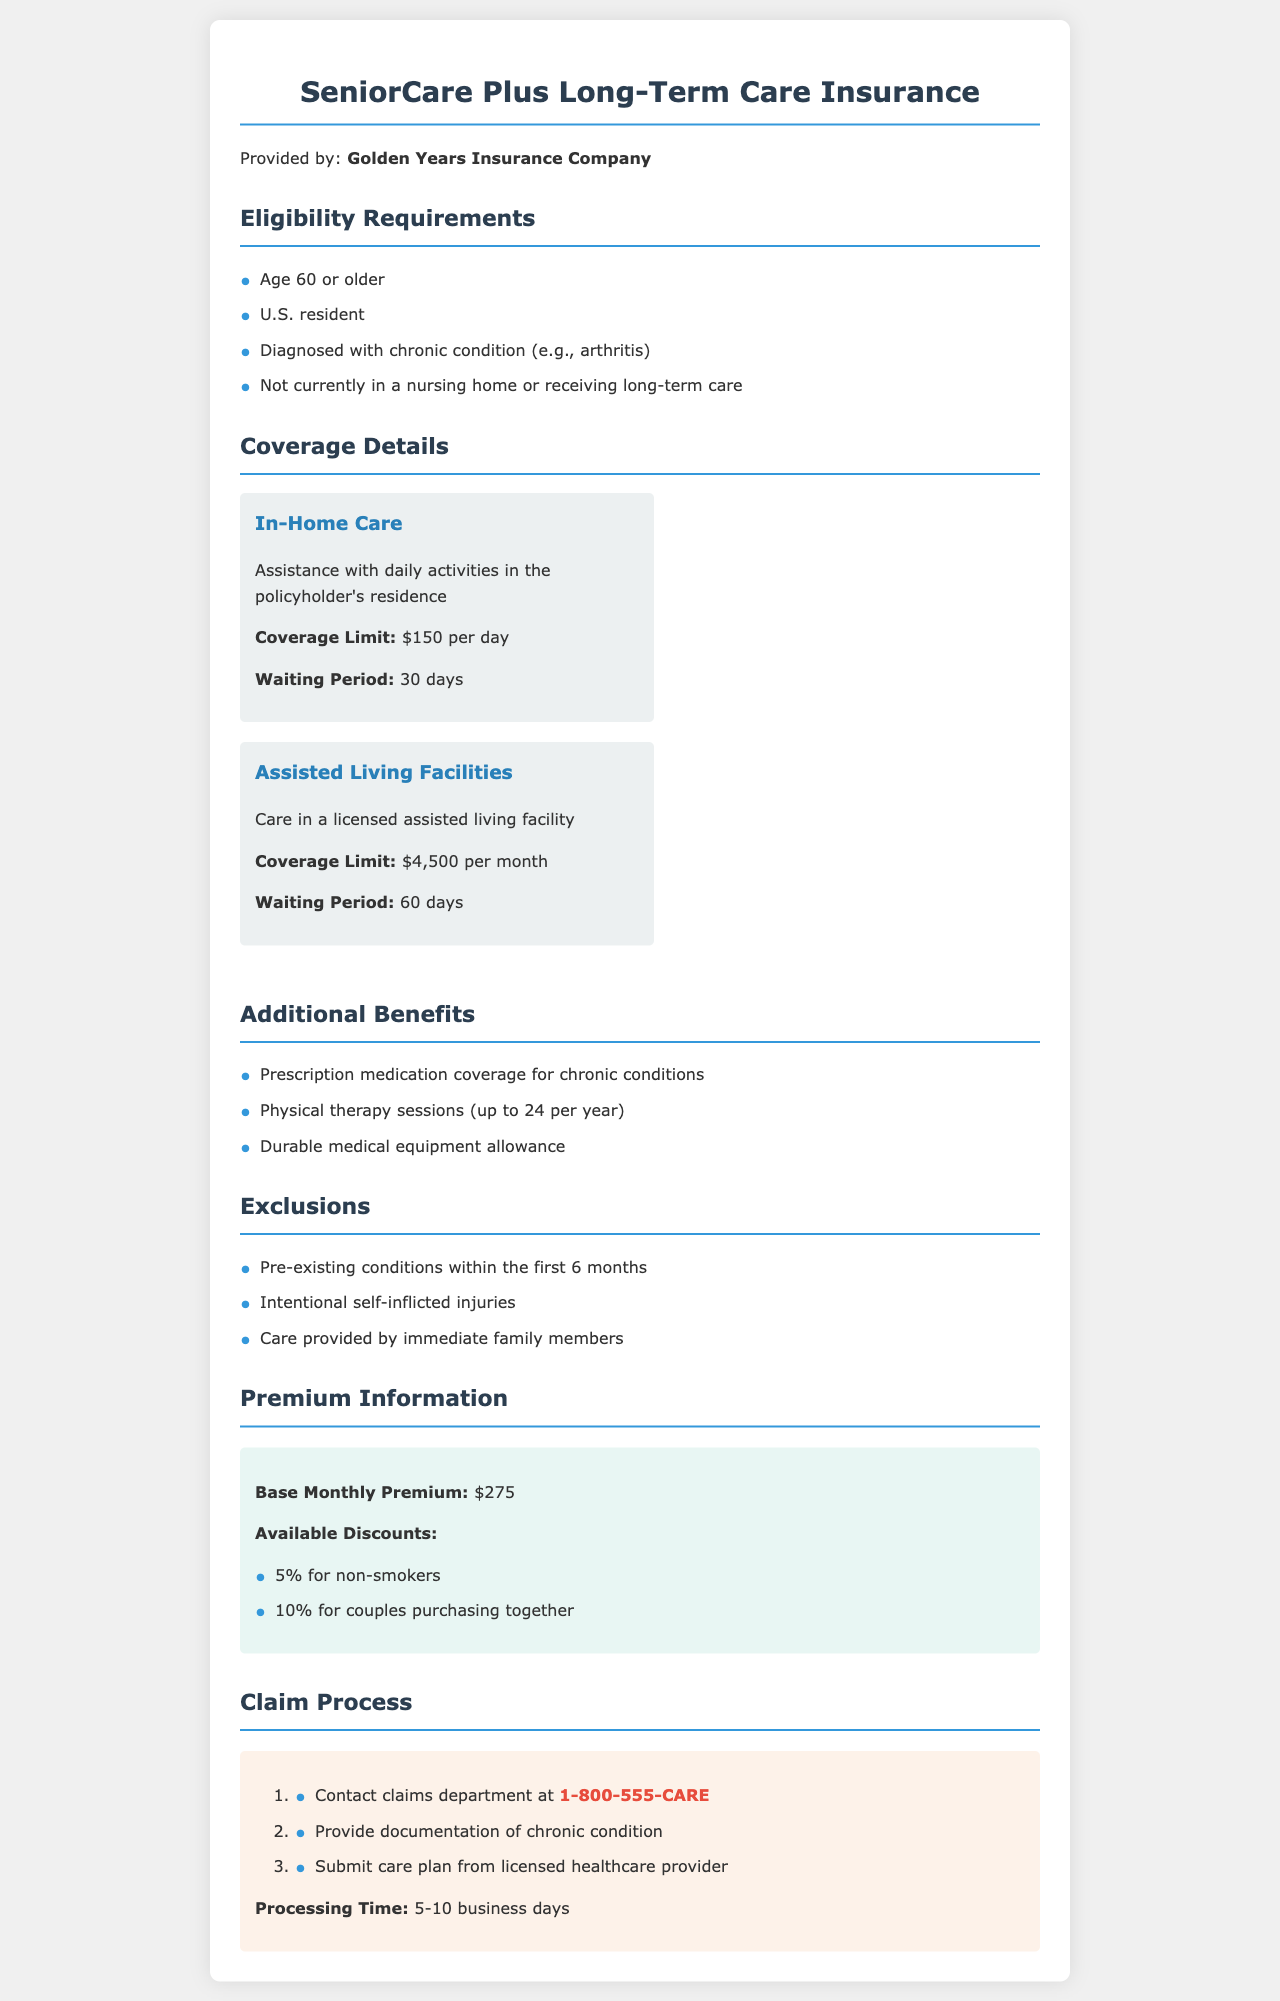What is the maximum daily coverage for in-home care? The maximum daily coverage for in-home care is specified in the document under coverage details.
Answer: $150 per day What is the waiting period for assisted living facility coverage? The waiting period for assisted living facility coverage is mentioned in the document.
Answer: 60 days What additional benefit includes up to 24 sessions per year? The document mentions additional benefits, one of which refers to sessions per year.
Answer: Physical therapy sessions Who provides the SeniorCare Plus Long-Term Care Insurance? The provider of the SeniorCare Plus Long-Term Care Insurance is given at the beginning of the document.
Answer: Golden Years Insurance Company What is the base monthly premium for this long-term care insurance? The base monthly premium can be found in the premium information section of the document.
Answer: $275 What is excluded regarding pre-existing conditions? Exclusions are detailed in the document, indicating something about pre-existing conditions.
Answer: Within the first 6 months How long does the claim process typically take? The processing time for claims is specified in the claim process section of the document.
Answer: 5-10 business days What chronic condition is specifically mentioned in eligibility requirements? The eligibility requirements list a certain chronic condition as an example.
Answer: Arthritis What document must be submitted by the policyholder to process a claim? The claim process section of the document specifies what document must be submitted.
Answer: Care plan from licensed healthcare provider 